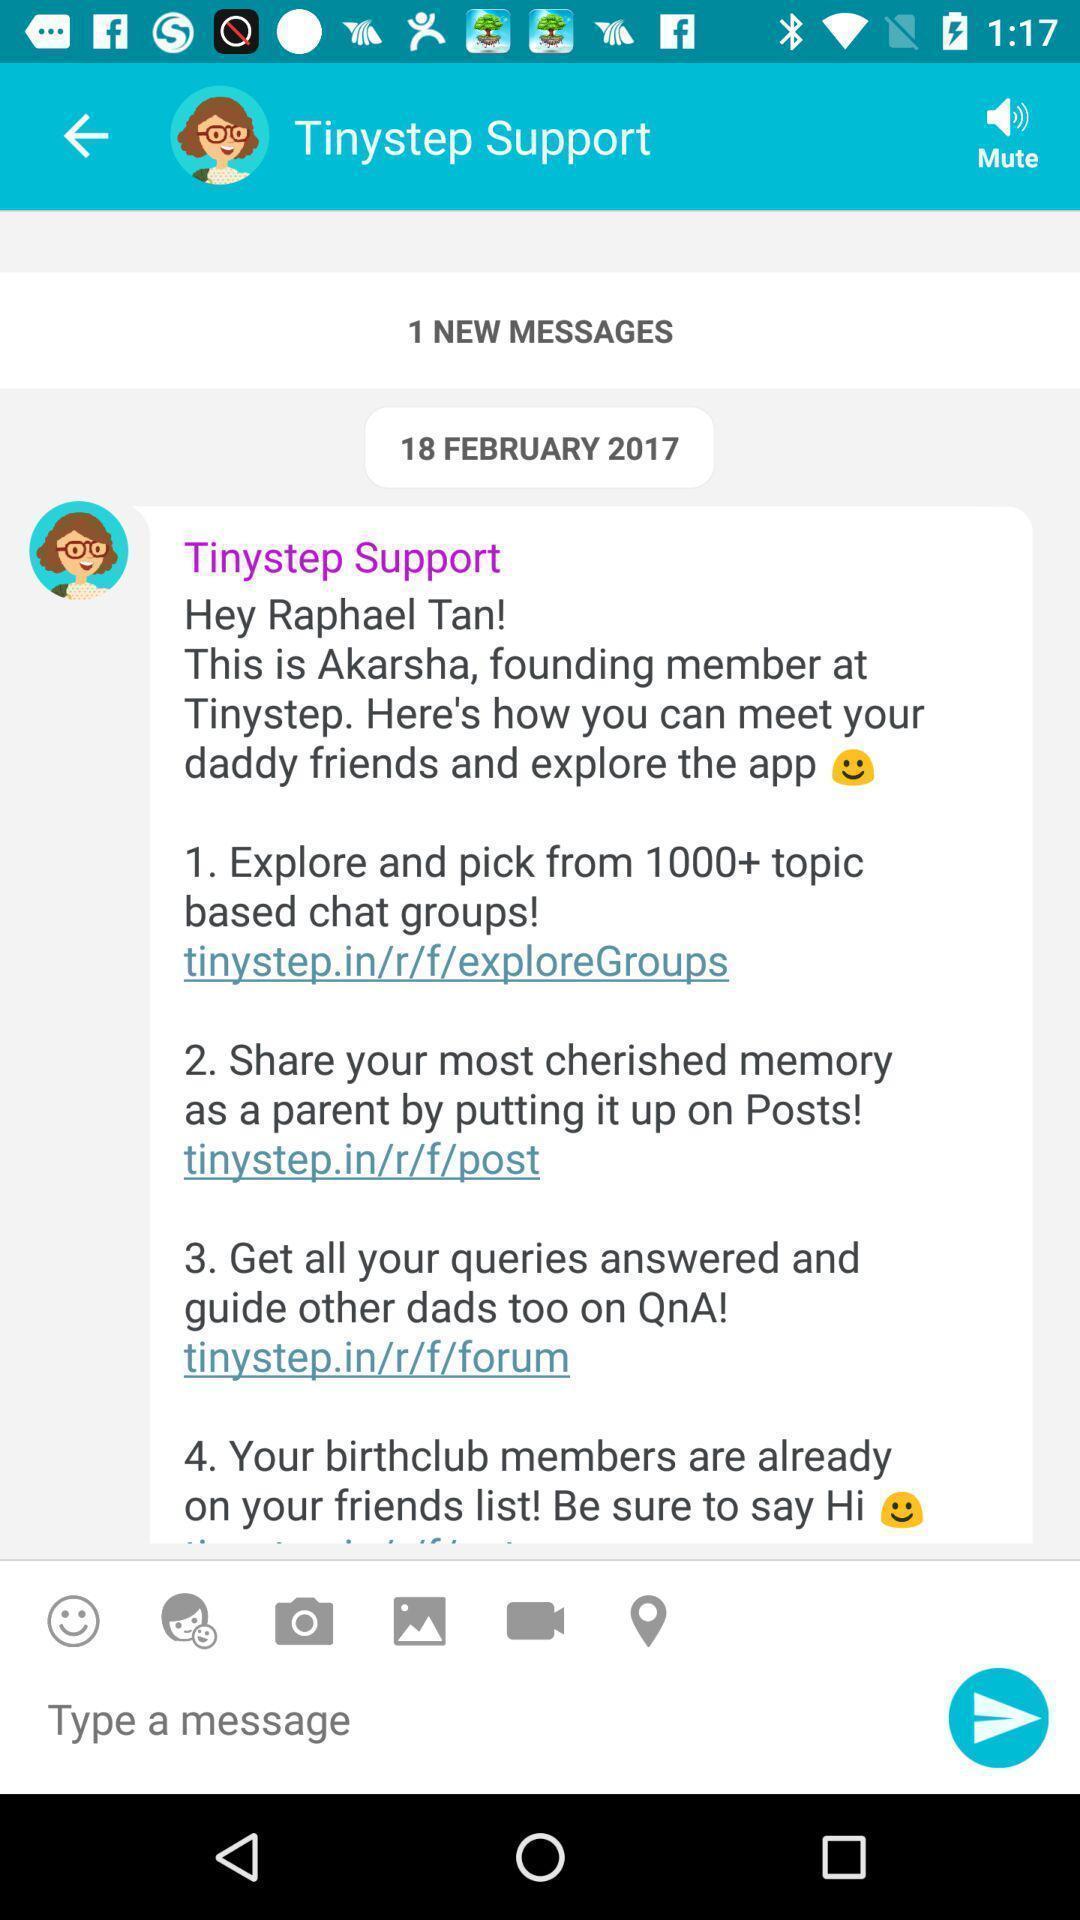Tell me about the visual elements in this screen capture. Page showing the chat box of social app. 